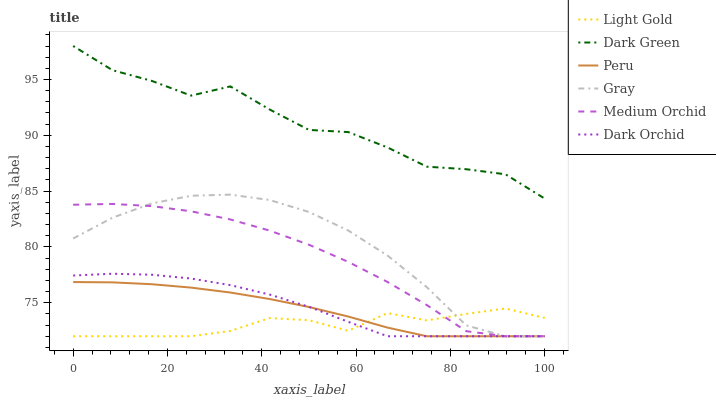Does Light Gold have the minimum area under the curve?
Answer yes or no. Yes. Does Dark Green have the maximum area under the curve?
Answer yes or no. Yes. Does Medium Orchid have the minimum area under the curve?
Answer yes or no. No. Does Medium Orchid have the maximum area under the curve?
Answer yes or no. No. Is Peru the smoothest?
Answer yes or no. Yes. Is Dark Green the roughest?
Answer yes or no. Yes. Is Medium Orchid the smoothest?
Answer yes or no. No. Is Medium Orchid the roughest?
Answer yes or no. No. Does Gray have the lowest value?
Answer yes or no. Yes. Does Dark Green have the lowest value?
Answer yes or no. No. Does Dark Green have the highest value?
Answer yes or no. Yes. Does Medium Orchid have the highest value?
Answer yes or no. No. Is Gray less than Dark Green?
Answer yes or no. Yes. Is Dark Green greater than Peru?
Answer yes or no. Yes. Does Medium Orchid intersect Light Gold?
Answer yes or no. Yes. Is Medium Orchid less than Light Gold?
Answer yes or no. No. Is Medium Orchid greater than Light Gold?
Answer yes or no. No. Does Gray intersect Dark Green?
Answer yes or no. No. 